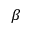Convert formula to latex. <formula><loc_0><loc_0><loc_500><loc_500>\beta</formula> 